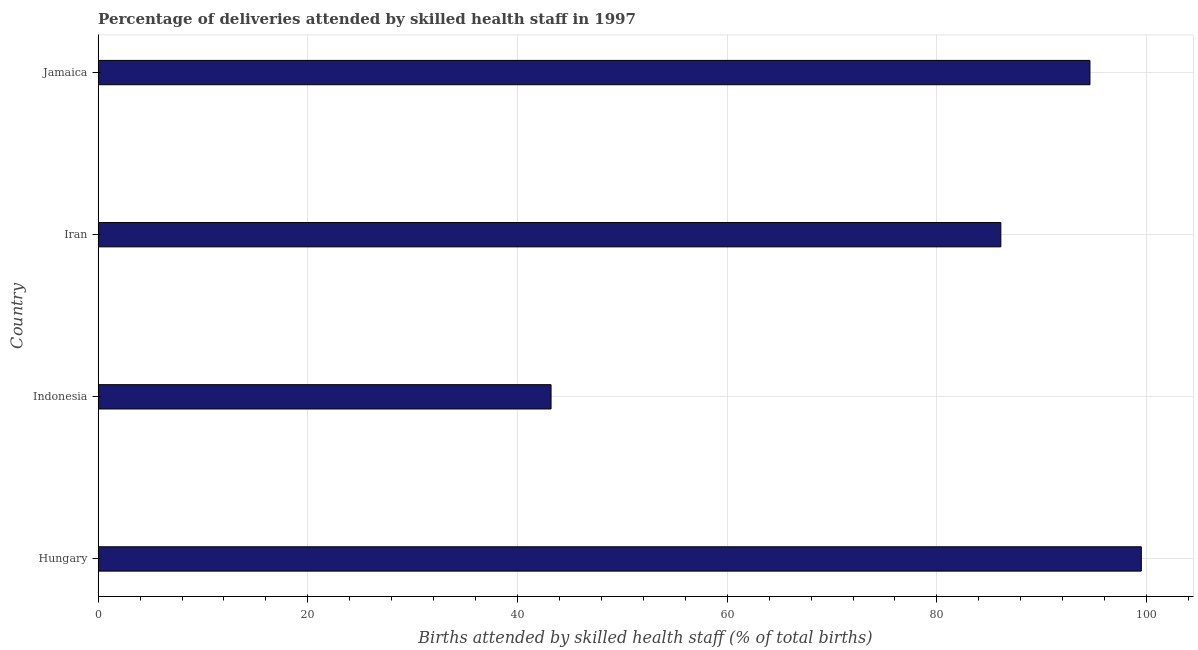Does the graph contain grids?
Offer a terse response. Yes. What is the title of the graph?
Make the answer very short. Percentage of deliveries attended by skilled health staff in 1997. What is the label or title of the X-axis?
Provide a succinct answer. Births attended by skilled health staff (% of total births). What is the label or title of the Y-axis?
Provide a short and direct response. Country. What is the number of births attended by skilled health staff in Hungary?
Your answer should be very brief. 99.5. Across all countries, what is the maximum number of births attended by skilled health staff?
Provide a succinct answer. 99.5. Across all countries, what is the minimum number of births attended by skilled health staff?
Your response must be concise. 43.2. In which country was the number of births attended by skilled health staff maximum?
Your response must be concise. Hungary. What is the sum of the number of births attended by skilled health staff?
Your response must be concise. 323.4. What is the difference between the number of births attended by skilled health staff in Indonesia and Jamaica?
Offer a terse response. -51.4. What is the average number of births attended by skilled health staff per country?
Offer a very short reply. 80.85. What is the median number of births attended by skilled health staff?
Offer a very short reply. 90.35. In how many countries, is the number of births attended by skilled health staff greater than 76 %?
Your response must be concise. 3. What is the ratio of the number of births attended by skilled health staff in Hungary to that in Jamaica?
Provide a succinct answer. 1.05. What is the difference between the highest and the lowest number of births attended by skilled health staff?
Provide a short and direct response. 56.3. How many bars are there?
Your answer should be very brief. 4. Are all the bars in the graph horizontal?
Your answer should be very brief. Yes. Are the values on the major ticks of X-axis written in scientific E-notation?
Your response must be concise. No. What is the Births attended by skilled health staff (% of total births) in Hungary?
Your response must be concise. 99.5. What is the Births attended by skilled health staff (% of total births) in Indonesia?
Keep it short and to the point. 43.2. What is the Births attended by skilled health staff (% of total births) of Iran?
Your answer should be very brief. 86.1. What is the Births attended by skilled health staff (% of total births) of Jamaica?
Give a very brief answer. 94.6. What is the difference between the Births attended by skilled health staff (% of total births) in Hungary and Indonesia?
Your answer should be compact. 56.3. What is the difference between the Births attended by skilled health staff (% of total births) in Indonesia and Iran?
Your response must be concise. -42.9. What is the difference between the Births attended by skilled health staff (% of total births) in Indonesia and Jamaica?
Your response must be concise. -51.4. What is the difference between the Births attended by skilled health staff (% of total births) in Iran and Jamaica?
Offer a very short reply. -8.5. What is the ratio of the Births attended by skilled health staff (% of total births) in Hungary to that in Indonesia?
Provide a short and direct response. 2.3. What is the ratio of the Births attended by skilled health staff (% of total births) in Hungary to that in Iran?
Provide a succinct answer. 1.16. What is the ratio of the Births attended by skilled health staff (% of total births) in Hungary to that in Jamaica?
Your answer should be compact. 1.05. What is the ratio of the Births attended by skilled health staff (% of total births) in Indonesia to that in Iran?
Ensure brevity in your answer.  0.5. What is the ratio of the Births attended by skilled health staff (% of total births) in Indonesia to that in Jamaica?
Provide a succinct answer. 0.46. What is the ratio of the Births attended by skilled health staff (% of total births) in Iran to that in Jamaica?
Provide a short and direct response. 0.91. 